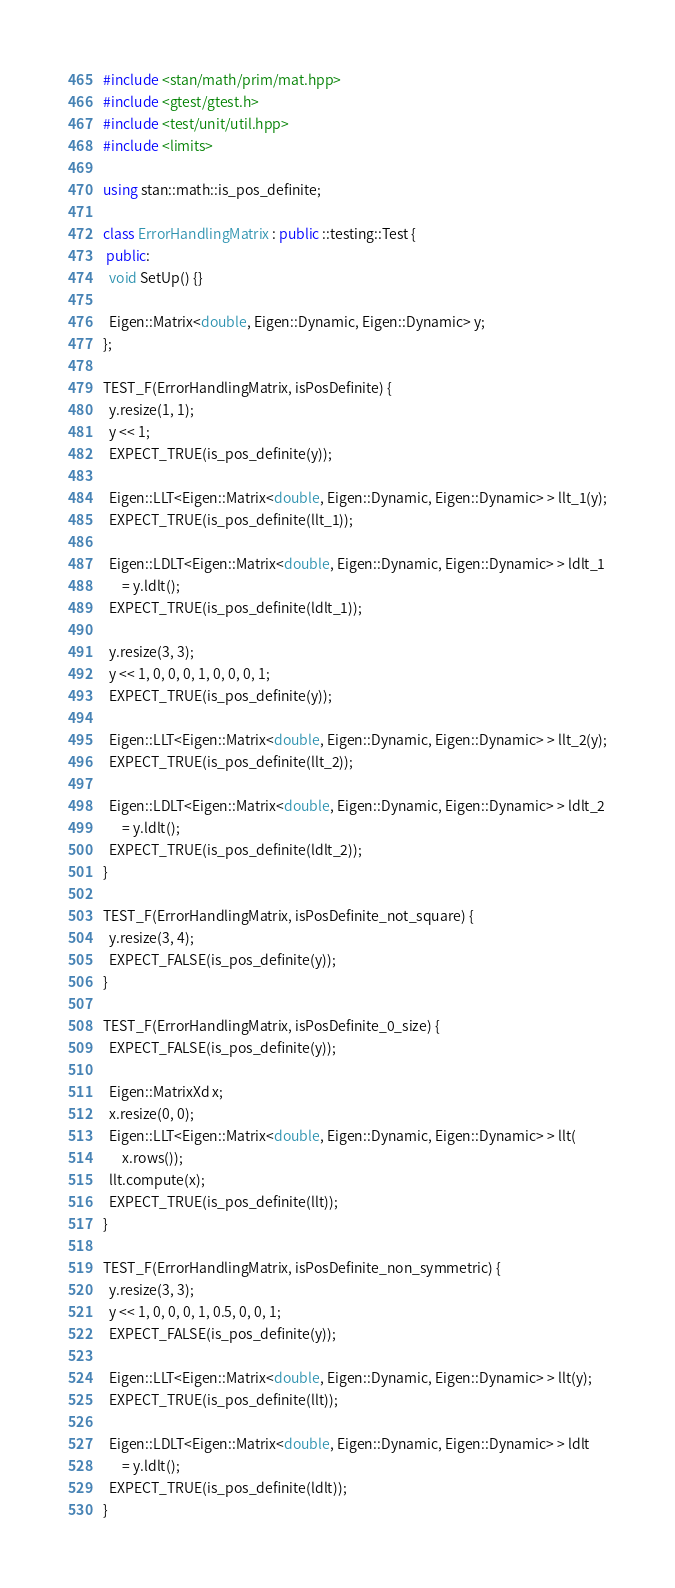<code> <loc_0><loc_0><loc_500><loc_500><_C++_>#include <stan/math/prim/mat.hpp>
#include <gtest/gtest.h>
#include <test/unit/util.hpp>
#include <limits>

using stan::math::is_pos_definite;

class ErrorHandlingMatrix : public ::testing::Test {
 public:
  void SetUp() {}

  Eigen::Matrix<double, Eigen::Dynamic, Eigen::Dynamic> y;
};

TEST_F(ErrorHandlingMatrix, isPosDefinite) {
  y.resize(1, 1);
  y << 1;
  EXPECT_TRUE(is_pos_definite(y));

  Eigen::LLT<Eigen::Matrix<double, Eigen::Dynamic, Eigen::Dynamic> > llt_1(y);
  EXPECT_TRUE(is_pos_definite(llt_1));

  Eigen::LDLT<Eigen::Matrix<double, Eigen::Dynamic, Eigen::Dynamic> > ldlt_1
      = y.ldlt();
  EXPECT_TRUE(is_pos_definite(ldlt_1));

  y.resize(3, 3);
  y << 1, 0, 0, 0, 1, 0, 0, 0, 1;
  EXPECT_TRUE(is_pos_definite(y));

  Eigen::LLT<Eigen::Matrix<double, Eigen::Dynamic, Eigen::Dynamic> > llt_2(y);
  EXPECT_TRUE(is_pos_definite(llt_2));

  Eigen::LDLT<Eigen::Matrix<double, Eigen::Dynamic, Eigen::Dynamic> > ldlt_2
      = y.ldlt();
  EXPECT_TRUE(is_pos_definite(ldlt_2));
}

TEST_F(ErrorHandlingMatrix, isPosDefinite_not_square) {
  y.resize(3, 4);
  EXPECT_FALSE(is_pos_definite(y));
}

TEST_F(ErrorHandlingMatrix, isPosDefinite_0_size) {
  EXPECT_FALSE(is_pos_definite(y));

  Eigen::MatrixXd x;
  x.resize(0, 0);
  Eigen::LLT<Eigen::Matrix<double, Eigen::Dynamic, Eigen::Dynamic> > llt(
      x.rows());
  llt.compute(x);
  EXPECT_TRUE(is_pos_definite(llt));
}

TEST_F(ErrorHandlingMatrix, isPosDefinite_non_symmetric) {
  y.resize(3, 3);
  y << 1, 0, 0, 0, 1, 0.5, 0, 0, 1;
  EXPECT_FALSE(is_pos_definite(y));

  Eigen::LLT<Eigen::Matrix<double, Eigen::Dynamic, Eigen::Dynamic> > llt(y);
  EXPECT_TRUE(is_pos_definite(llt));

  Eigen::LDLT<Eigen::Matrix<double, Eigen::Dynamic, Eigen::Dynamic> > ldlt
      = y.ldlt();
  EXPECT_TRUE(is_pos_definite(ldlt));
}
</code> 